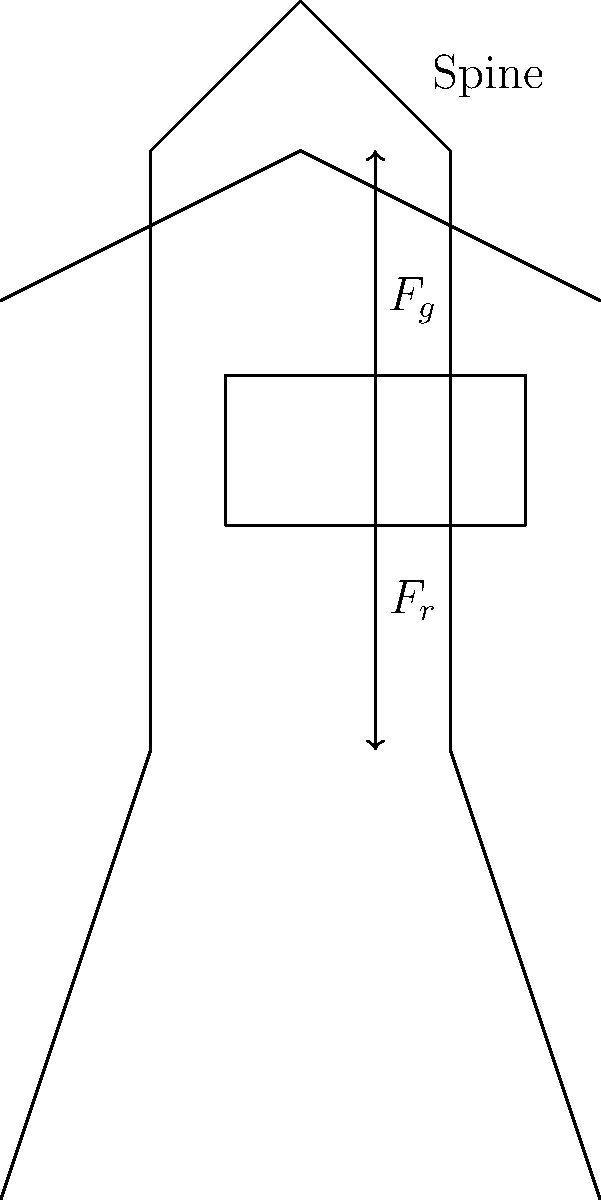When an occupational therapist instructs a patient on proper lifting techniques, how does increasing the weight of an object affect the compressive force on the spine? Explain using the force distribution shown in the diagram. To understand how increasing the weight of an object affects the compressive force on the spine, let's follow these steps:

1. Identify forces: In the diagram, we see two main forces:
   - $F_g$: the gravitational force of the object being lifted (pointing downward)
   - $F_r$: the reactive force from the muscles and skeletal structure (pointing upward)

2. Understand force balance: For the person to remain stable while lifting, these forces must be in equilibrium. Thus, $F_r = F_g$ in magnitude.

3. Analyze spine compression: The compressive force on the spine is the sum of these two forces, as they both act along the spine's axis. 
   Compressive Force = $F_g + F_r = 2F_g$

4. Consider weight increase: If we increase the weight of the object:
   - $F_g$ increases proportionally to the weight increase
   - To maintain balance, $F_r$ must increase by the same amount

5. Calculate new compressive force: With a heavier object, both $F_g$ and $F_r$ increase, leading to a greater total compressive force on the spine.

6. Proportional relationship: The compressive force on the spine increases proportionally to the increase in the object's weight. For example, doubling the weight would double the compressive force.

This understanding is crucial for occupational therapists when teaching proper lifting techniques to patients, as it emphasizes the importance of proper body mechanics and the potential risks of lifting heavy objects incorrectly.
Answer: Compressive force on the spine increases proportionally to the object's weight increase. 